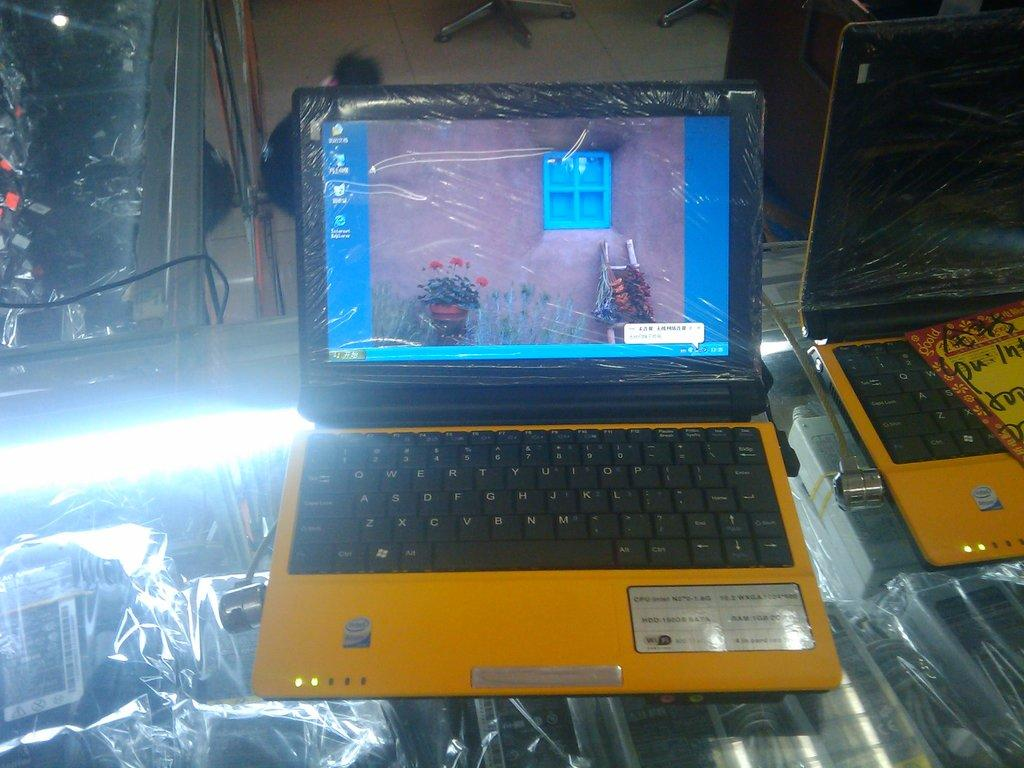<image>
Provide a brief description of the given image. the name Intel is on the yellow laptop 